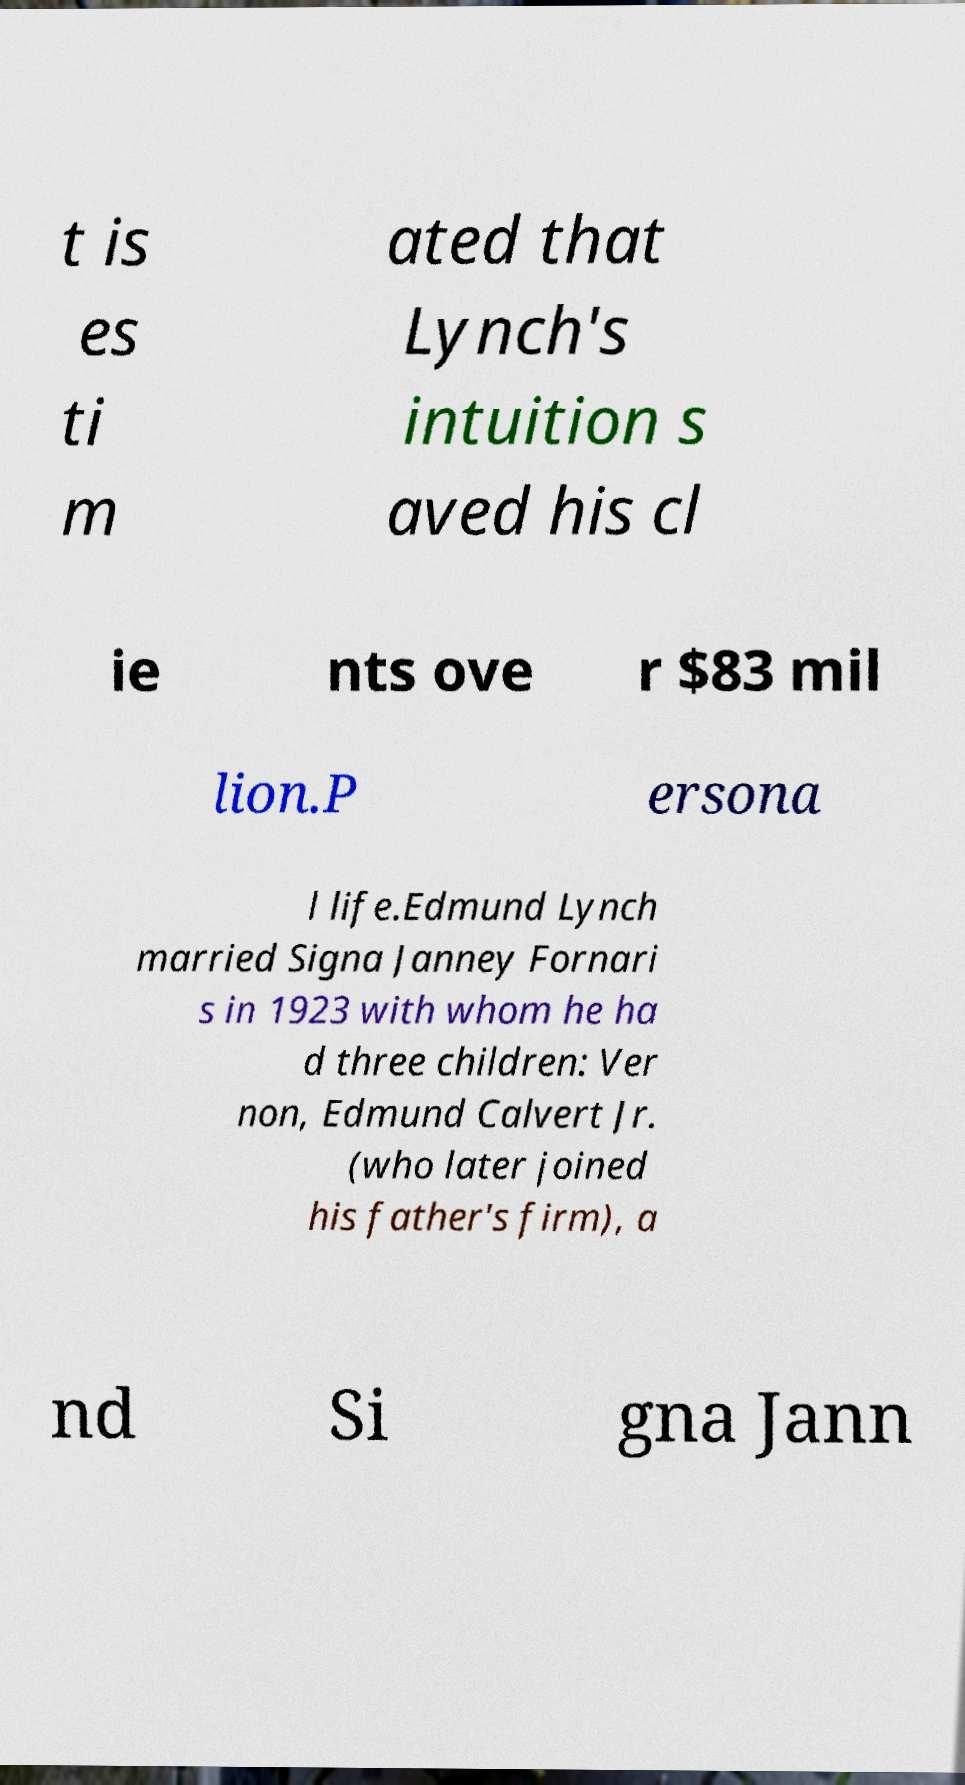There's text embedded in this image that I need extracted. Can you transcribe it verbatim? t is es ti m ated that Lynch's intuition s aved his cl ie nts ove r $83 mil lion.P ersona l life.Edmund Lynch married Signa Janney Fornari s in 1923 with whom he ha d three children: Ver non, Edmund Calvert Jr. (who later joined his father's firm), a nd Si gna Jann 